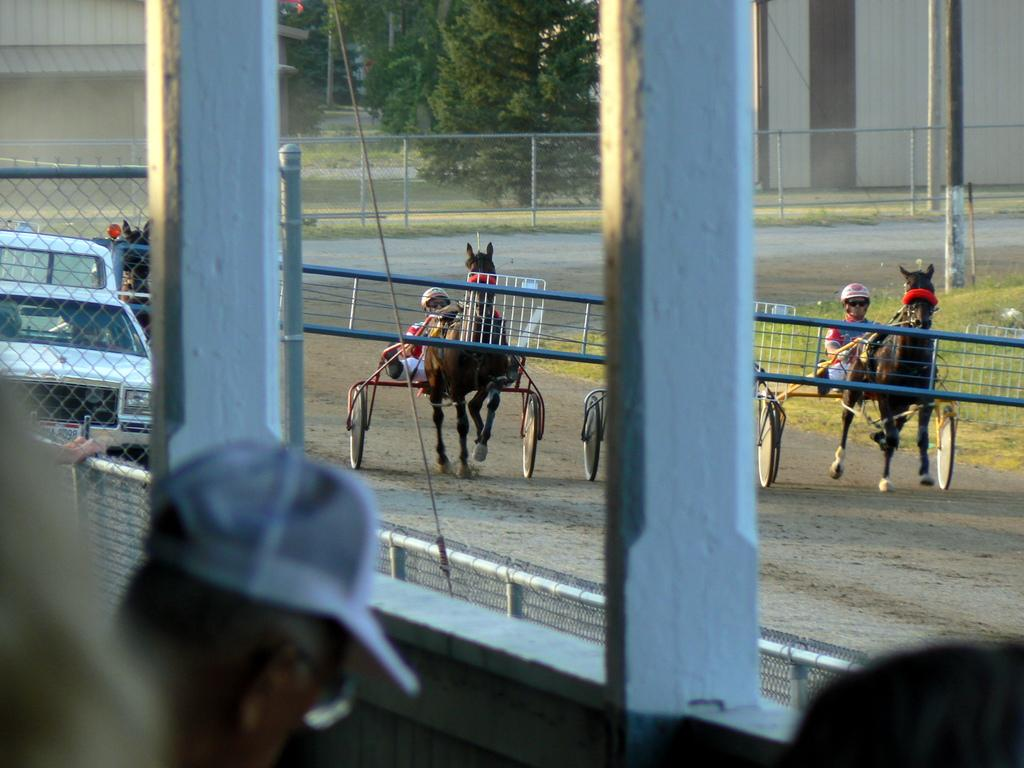What types of vehicles can be seen in the image? There are vehicles in the image, including horse carts. What else can be seen on the road besides vehicles? There are people present in the image. What architectural features are visible in the image? Pillars are visible in the image. What can be seen in the background of the image? There are buildings, trees, and a fence in the background of the image. How many vests are hanging on the fence in the image? There are no vests present in the image; it features vehicles, people, pillars, buildings, trees, and a fence. What type of vase can be seen on the horse cart in the image? There is no vase present on the horse cart in the image; it features vehicles, people, and pillars. 